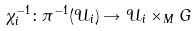<formula> <loc_0><loc_0><loc_500><loc_500>\chi _ { i } ^ { - 1 } \colon \pi ^ { - 1 } ( \mathcal { U } _ { i } ) \rightarrow \mathcal { U } _ { i } \times _ { M } G</formula> 